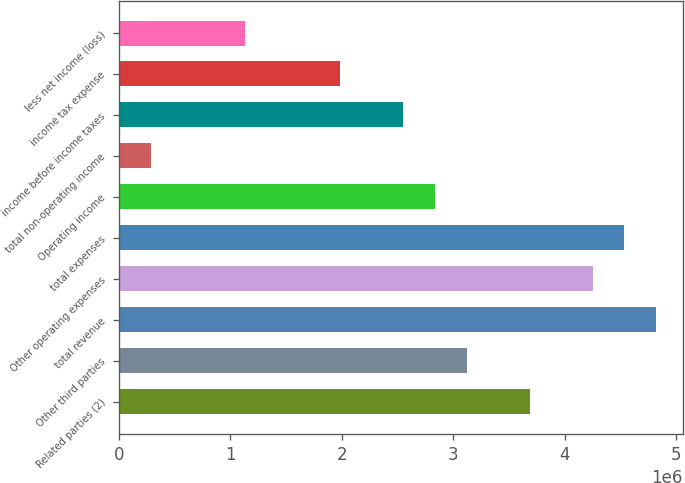<chart> <loc_0><loc_0><loc_500><loc_500><bar_chart><fcel>Related parties (2)<fcel>Other third parties<fcel>total revenue<fcel>Other operating expenses<fcel>total expenses<fcel>Operating income<fcel>total non-operating income<fcel>income before income taxes<fcel>income tax expense<fcel>less net income (loss)<nl><fcel>3.68655e+06<fcel>3.11939e+06<fcel>4.82088e+06<fcel>4.25372e+06<fcel>4.5373e+06<fcel>2.83581e+06<fcel>283584<fcel>2.55223e+06<fcel>1.98507e+06<fcel>1.13433e+06<nl></chart> 